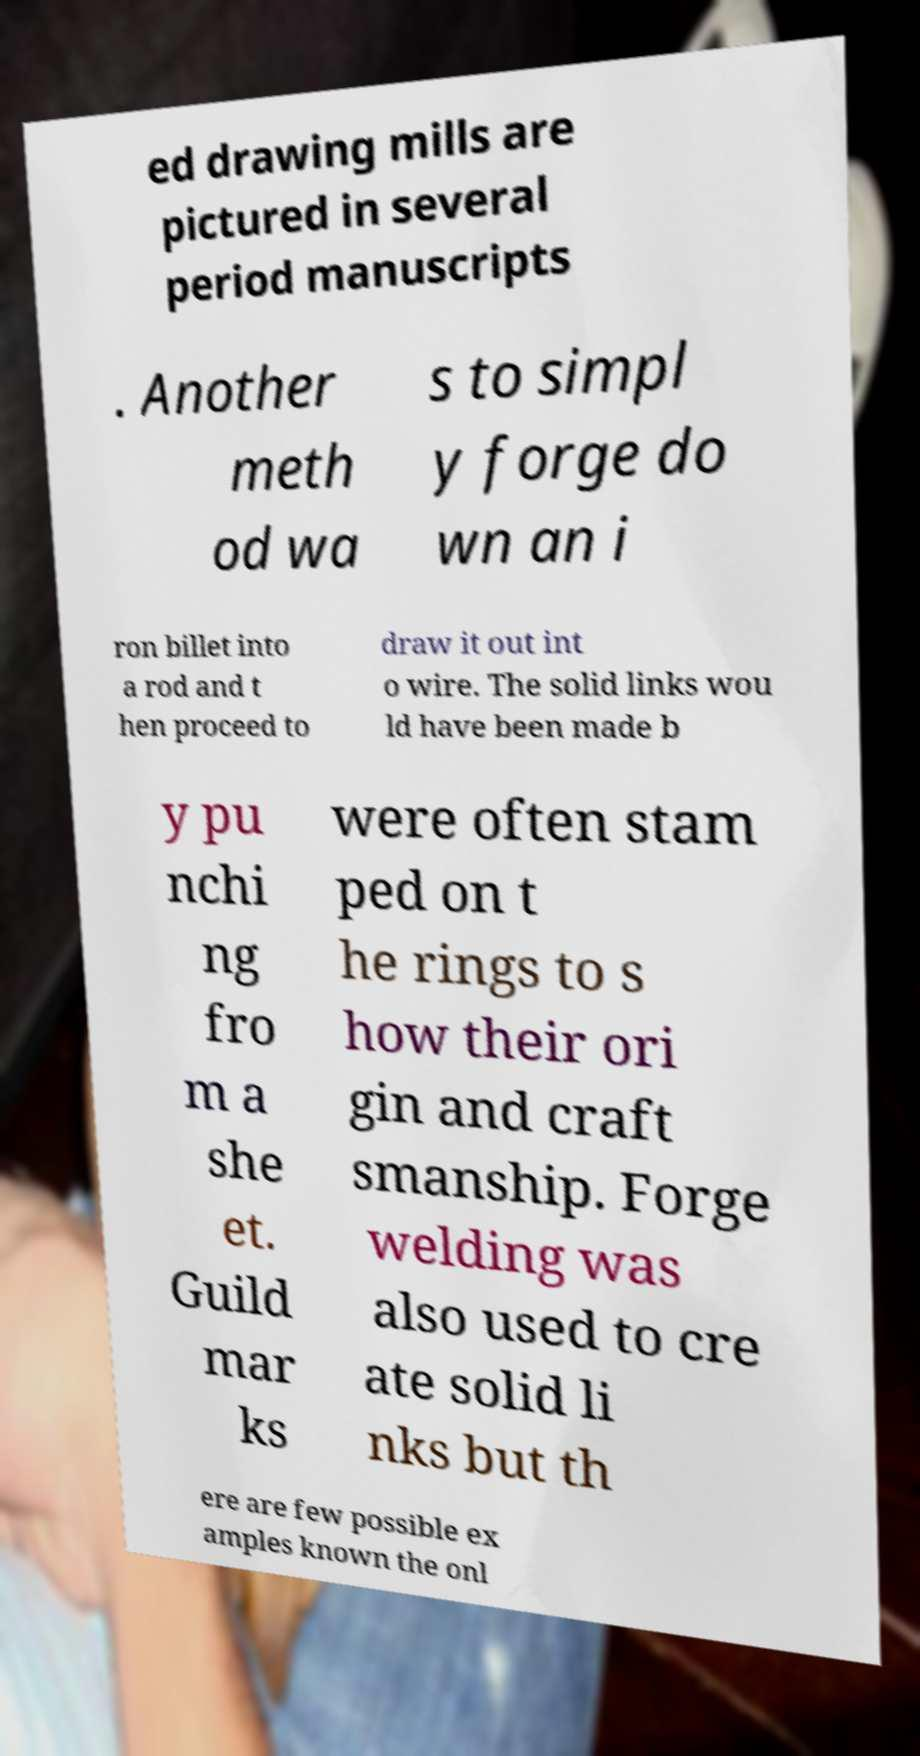There's text embedded in this image that I need extracted. Can you transcribe it verbatim? ed drawing mills are pictured in several period manuscripts . Another meth od wa s to simpl y forge do wn an i ron billet into a rod and t hen proceed to draw it out int o wire. The solid links wou ld have been made b y pu nchi ng fro m a she et. Guild mar ks were often stam ped on t he rings to s how their ori gin and craft smanship. Forge welding was also used to cre ate solid li nks but th ere are few possible ex amples known the onl 